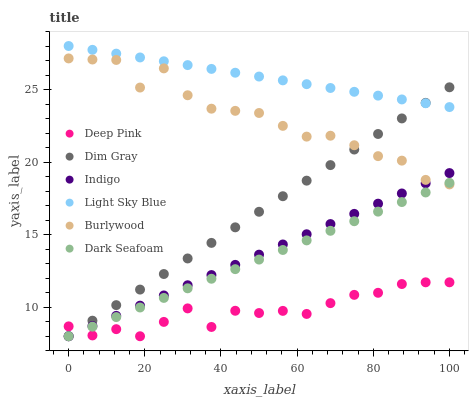Does Deep Pink have the minimum area under the curve?
Answer yes or no. Yes. Does Light Sky Blue have the maximum area under the curve?
Answer yes or no. Yes. Does Indigo have the minimum area under the curve?
Answer yes or no. No. Does Indigo have the maximum area under the curve?
Answer yes or no. No. Is Dark Seafoam the smoothest?
Answer yes or no. Yes. Is Burlywood the roughest?
Answer yes or no. Yes. Is Indigo the smoothest?
Answer yes or no. No. Is Indigo the roughest?
Answer yes or no. No. Does Dim Gray have the lowest value?
Answer yes or no. Yes. Does Burlywood have the lowest value?
Answer yes or no. No. Does Light Sky Blue have the highest value?
Answer yes or no. Yes. Does Indigo have the highest value?
Answer yes or no. No. Is Burlywood less than Light Sky Blue?
Answer yes or no. Yes. Is Light Sky Blue greater than Burlywood?
Answer yes or no. Yes. Does Burlywood intersect Indigo?
Answer yes or no. Yes. Is Burlywood less than Indigo?
Answer yes or no. No. Is Burlywood greater than Indigo?
Answer yes or no. No. Does Burlywood intersect Light Sky Blue?
Answer yes or no. No. 